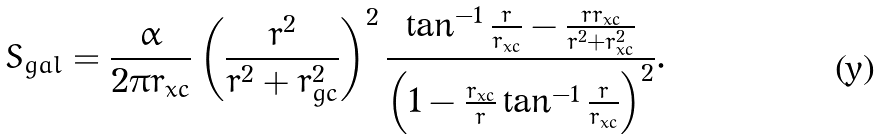Convert formula to latex. <formula><loc_0><loc_0><loc_500><loc_500>S _ { g a l } = \frac { \alpha } { 2 \pi r _ { x c } } \left ( \frac { r ^ { 2 } } { r ^ { 2 } + r _ { g c } ^ { 2 } } \right ) ^ { 2 } \frac { \tan ^ { - 1 } \frac { r } { r _ { x c } } - \frac { r r _ { x c } } { r ^ { 2 } + r _ { x c } ^ { 2 } } } { \left ( 1 - \frac { r _ { x c } } { r } \tan ^ { - 1 } \frac { r } { r _ { x c } } \right ) ^ { 2 } } .</formula> 